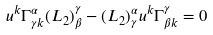<formula> <loc_0><loc_0><loc_500><loc_500>u ^ { k } \Gamma _ { \gamma k } ^ { \alpha } ( L _ { 2 } ) ^ { \gamma } _ { \beta } - ( L _ { 2 } ) ^ { \alpha } _ { \gamma } u ^ { k } \Gamma ^ { \gamma } _ { \beta k } = 0</formula> 